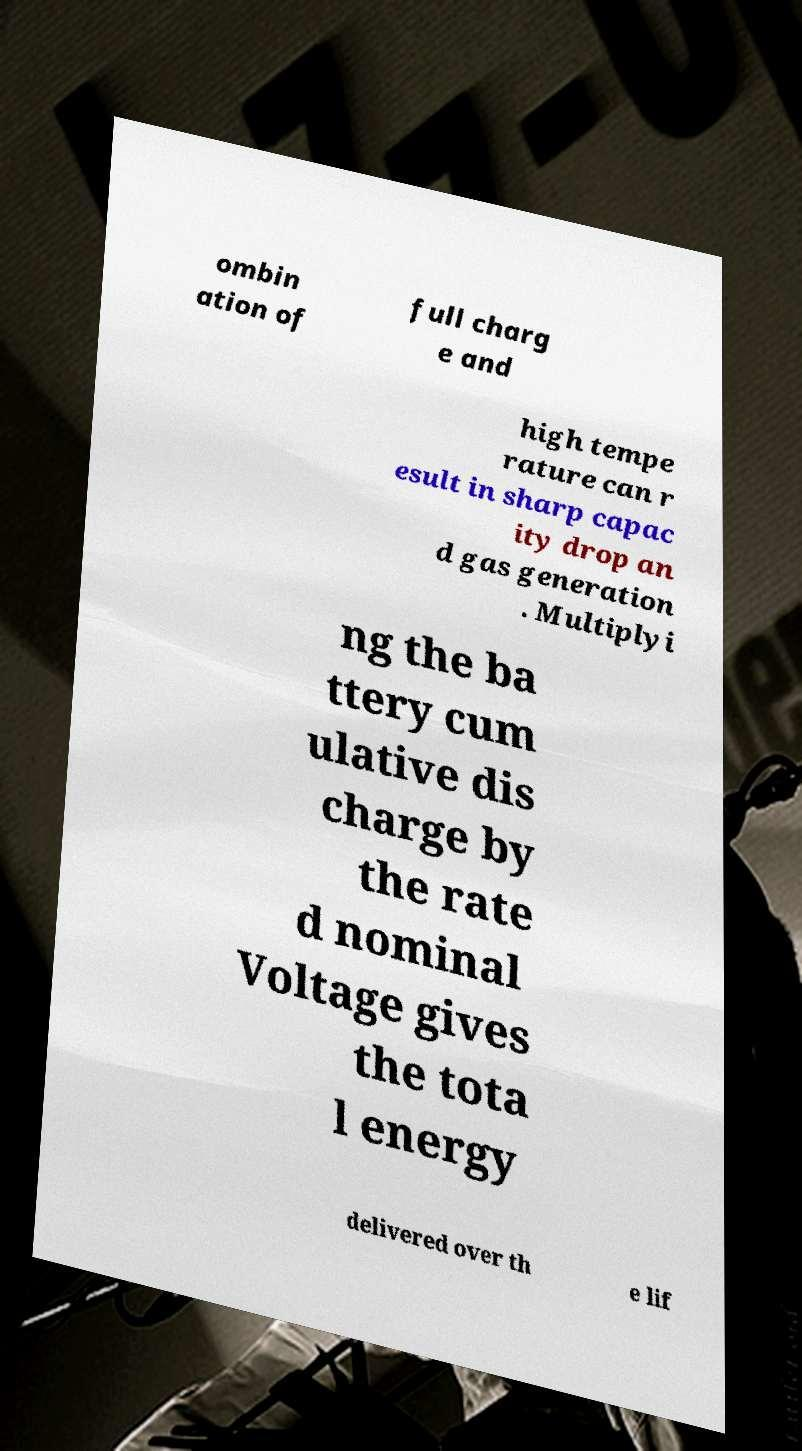For documentation purposes, I need the text within this image transcribed. Could you provide that? ombin ation of full charg e and high tempe rature can r esult in sharp capac ity drop an d gas generation . Multiplyi ng the ba ttery cum ulative dis charge by the rate d nominal Voltage gives the tota l energy delivered over th e lif 